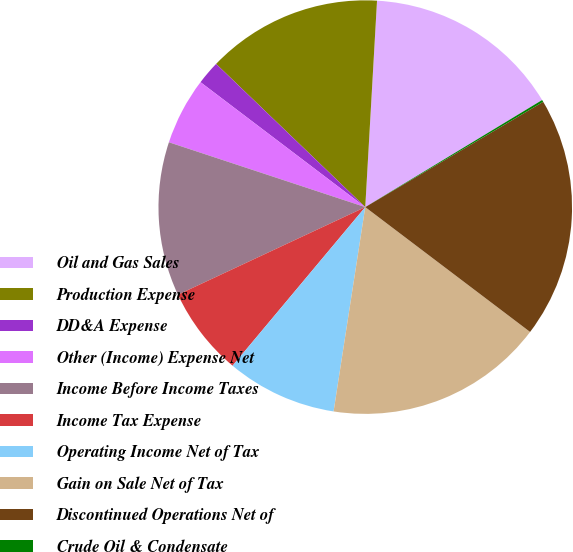Convert chart to OTSL. <chart><loc_0><loc_0><loc_500><loc_500><pie_chart><fcel>Oil and Gas Sales<fcel>Production Expense<fcel>DD&A Expense<fcel>Other (Income) Expense Net<fcel>Income Before Income Taxes<fcel>Income Tax Expense<fcel>Operating Income Net of Tax<fcel>Gain on Sale Net of Tax<fcel>Discontinued Operations Net of<fcel>Crude Oil & Condensate<nl><fcel>15.43%<fcel>13.73%<fcel>1.85%<fcel>5.25%<fcel>12.04%<fcel>6.95%<fcel>8.64%<fcel>17.13%<fcel>18.82%<fcel>0.16%<nl></chart> 